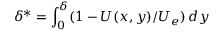<formula> <loc_0><loc_0><loc_500><loc_500>\delta ^ { * } = \int _ { 0 } ^ { \delta } ( 1 - U ( x , y ) / U _ { e } ) \, d y</formula> 